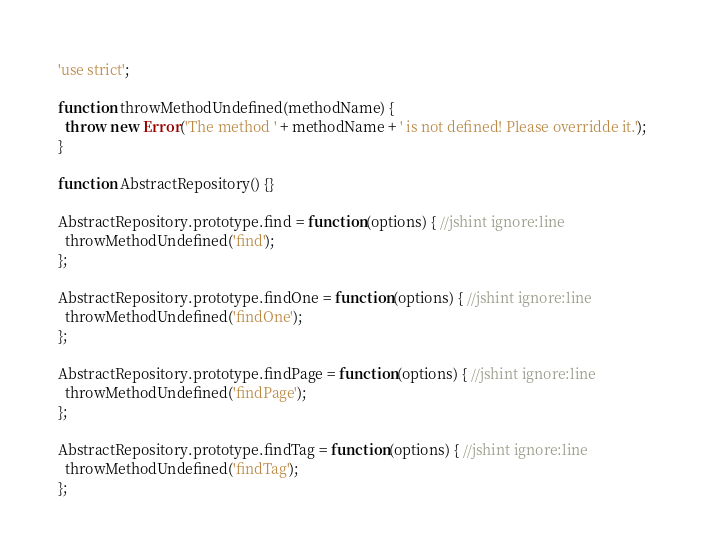<code> <loc_0><loc_0><loc_500><loc_500><_JavaScript_>'use strict';

function throwMethodUndefined(methodName) {
  throw new Error('The method ' + methodName + ' is not defined! Please overridde it.');
}

function AbstractRepository() {}

AbstractRepository.prototype.find = function(options) { //jshint ignore:line
  throwMethodUndefined('find');
};

AbstractRepository.prototype.findOne = function(options) { //jshint ignore:line
  throwMethodUndefined('findOne');
};

AbstractRepository.prototype.findPage = function(options) { //jshint ignore:line
  throwMethodUndefined('findPage');
};

AbstractRepository.prototype.findTag = function(options) { //jshint ignore:line
  throwMethodUndefined('findTag');
};
</code> 